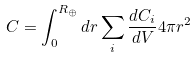<formula> <loc_0><loc_0><loc_500><loc_500>C = \int _ { 0 } ^ { R _ { \oplus } } d r \sum _ { i } \frac { d C _ { i } } { d V } 4 \pi r ^ { 2 }</formula> 